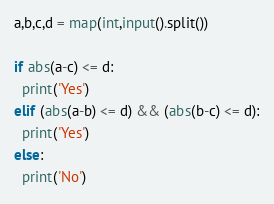Convert code to text. <code><loc_0><loc_0><loc_500><loc_500><_Python_>a,b,c,d = map(int,input().split())

if abs(a-c) <= d:
  print('Yes')
elif (abs(a-b) <= d) && (abs(b-c) <= d):
  print('Yes')
else:
  print('No')
</code> 